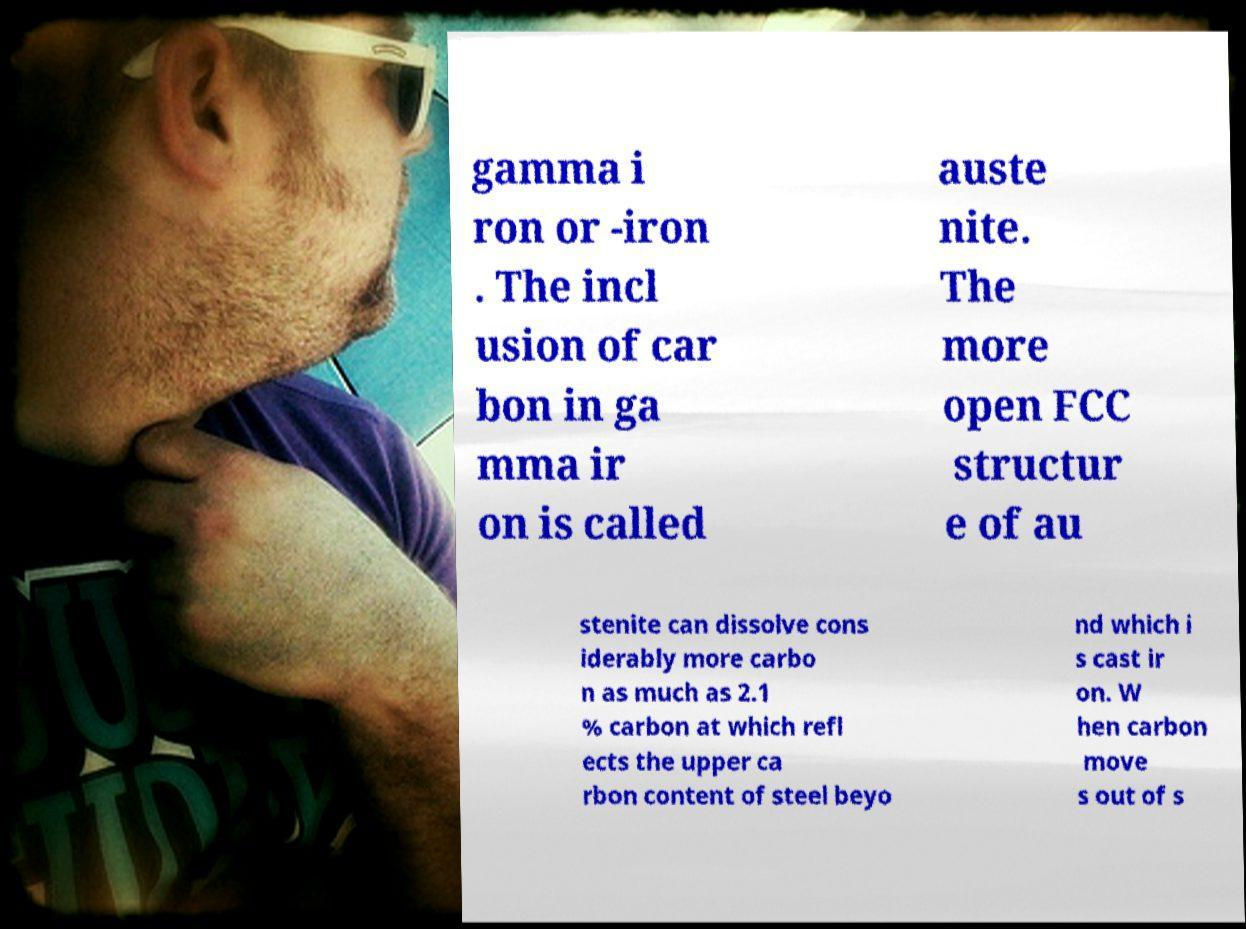I need the written content from this picture converted into text. Can you do that? gamma i ron or -iron . The incl usion of car bon in ga mma ir on is called auste nite. The more open FCC structur e of au stenite can dissolve cons iderably more carbo n as much as 2.1 % carbon at which refl ects the upper ca rbon content of steel beyo nd which i s cast ir on. W hen carbon move s out of s 